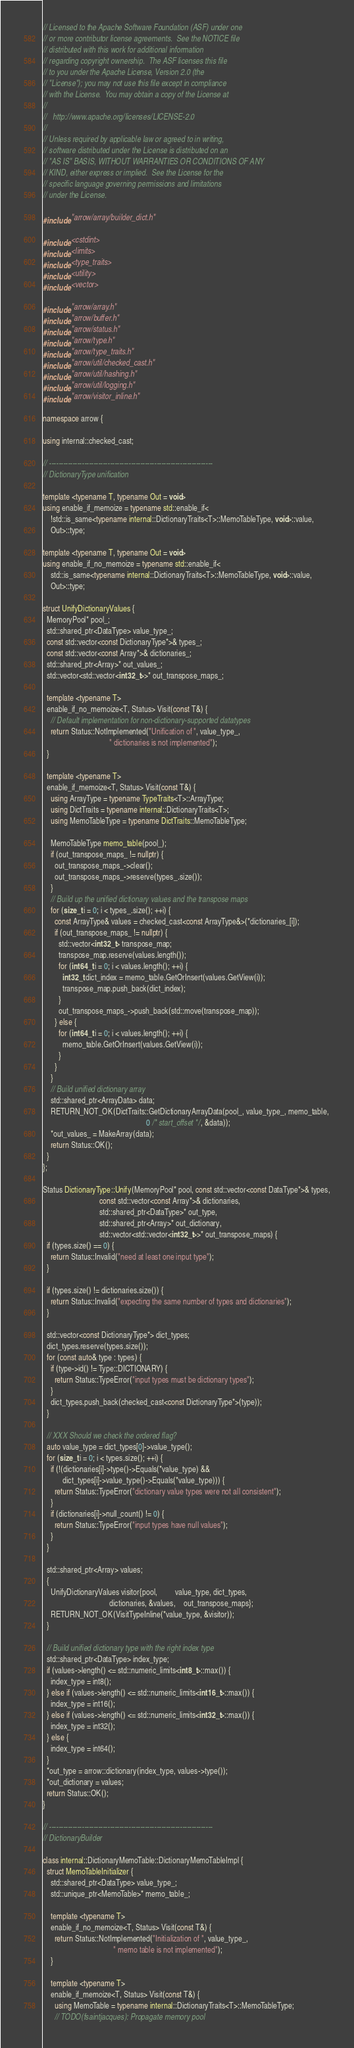Convert code to text. <code><loc_0><loc_0><loc_500><loc_500><_C++_>// Licensed to the Apache Software Foundation (ASF) under one
// or more contributor license agreements.  See the NOTICE file
// distributed with this work for additional information
// regarding copyright ownership.  The ASF licenses this file
// to you under the Apache License, Version 2.0 (the
// "License"); you may not use this file except in compliance
// with the License.  You may obtain a copy of the License at
//
//   http://www.apache.org/licenses/LICENSE-2.0
//
// Unless required by applicable law or agreed to in writing,
// software distributed under the License is distributed on an
// "AS IS" BASIS, WITHOUT WARRANTIES OR CONDITIONS OF ANY
// KIND, either express or implied.  See the License for the
// specific language governing permissions and limitations
// under the License.

#include "arrow/array/builder_dict.h"

#include <cstdint>
#include <limits>
#include <type_traits>
#include <utility>
#include <vector>

#include "arrow/array.h"
#include "arrow/buffer.h"
#include "arrow/status.h"
#include "arrow/type.h"
#include "arrow/type_traits.h"
#include "arrow/util/checked_cast.h"
#include "arrow/util/hashing.h"
#include "arrow/util/logging.h"
#include "arrow/visitor_inline.h"

namespace arrow {

using internal::checked_cast;

// ----------------------------------------------------------------------
// DictionaryType unification

template <typename T, typename Out = void>
using enable_if_memoize = typename std::enable_if<
    !std::is_same<typename internal::DictionaryTraits<T>::MemoTableType, void>::value,
    Out>::type;

template <typename T, typename Out = void>
using enable_if_no_memoize = typename std::enable_if<
    std::is_same<typename internal::DictionaryTraits<T>::MemoTableType, void>::value,
    Out>::type;

struct UnifyDictionaryValues {
  MemoryPool* pool_;
  std::shared_ptr<DataType> value_type_;
  const std::vector<const DictionaryType*>& types_;
  const std::vector<const Array*>& dictionaries_;
  std::shared_ptr<Array>* out_values_;
  std::vector<std::vector<int32_t>>* out_transpose_maps_;

  template <typename T>
  enable_if_no_memoize<T, Status> Visit(const T&) {
    // Default implementation for non-dictionary-supported datatypes
    return Status::NotImplemented("Unification of ", value_type_,
                                  " dictionaries is not implemented");
  }

  template <typename T>
  enable_if_memoize<T, Status> Visit(const T&) {
    using ArrayType = typename TypeTraits<T>::ArrayType;
    using DictTraits = typename internal::DictionaryTraits<T>;
    using MemoTableType = typename DictTraits::MemoTableType;

    MemoTableType memo_table(pool_);
    if (out_transpose_maps_ != nullptr) {
      out_transpose_maps_->clear();
      out_transpose_maps_->reserve(types_.size());
    }
    // Build up the unified dictionary values and the transpose maps
    for (size_t i = 0; i < types_.size(); ++i) {
      const ArrayType& values = checked_cast<const ArrayType&>(*dictionaries_[i]);
      if (out_transpose_maps_ != nullptr) {
        std::vector<int32_t> transpose_map;
        transpose_map.reserve(values.length());
        for (int64_t i = 0; i < values.length(); ++i) {
          int32_t dict_index = memo_table.GetOrInsert(values.GetView(i));
          transpose_map.push_back(dict_index);
        }
        out_transpose_maps_->push_back(std::move(transpose_map));
      } else {
        for (int64_t i = 0; i < values.length(); ++i) {
          memo_table.GetOrInsert(values.GetView(i));
        }
      }
    }
    // Build unified dictionary array
    std::shared_ptr<ArrayData> data;
    RETURN_NOT_OK(DictTraits::GetDictionaryArrayData(pool_, value_type_, memo_table,
                                                     0 /* start_offset */, &data));
    *out_values_ = MakeArray(data);
    return Status::OK();
  }
};

Status DictionaryType::Unify(MemoryPool* pool, const std::vector<const DataType*>& types,
                             const std::vector<const Array*>& dictionaries,
                             std::shared_ptr<DataType>* out_type,
                             std::shared_ptr<Array>* out_dictionary,
                             std::vector<std::vector<int32_t>>* out_transpose_maps) {
  if (types.size() == 0) {
    return Status::Invalid("need at least one input type");
  }

  if (types.size() != dictionaries.size()) {
    return Status::Invalid("expecting the same number of types and dictionaries");
  }

  std::vector<const DictionaryType*> dict_types;
  dict_types.reserve(types.size());
  for (const auto& type : types) {
    if (type->id() != Type::DICTIONARY) {
      return Status::TypeError("input types must be dictionary types");
    }
    dict_types.push_back(checked_cast<const DictionaryType*>(type));
  }

  // XXX Should we check the ordered flag?
  auto value_type = dict_types[0]->value_type();
  for (size_t i = 0; i < types.size(); ++i) {
    if (!(dictionaries[i]->type()->Equals(*value_type) &&
          dict_types[i]->value_type()->Equals(*value_type))) {
      return Status::TypeError("dictionary value types were not all consistent");
    }
    if (dictionaries[i]->null_count() != 0) {
      return Status::TypeError("input types have null values");
    }
  }

  std::shared_ptr<Array> values;
  {
    UnifyDictionaryValues visitor{pool,         value_type, dict_types,
                                  dictionaries, &values,    out_transpose_maps};
    RETURN_NOT_OK(VisitTypeInline(*value_type, &visitor));
  }

  // Build unified dictionary type with the right index type
  std::shared_ptr<DataType> index_type;
  if (values->length() <= std::numeric_limits<int8_t>::max()) {
    index_type = int8();
  } else if (values->length() <= std::numeric_limits<int16_t>::max()) {
    index_type = int16();
  } else if (values->length() <= std::numeric_limits<int32_t>::max()) {
    index_type = int32();
  } else {
    index_type = int64();
  }
  *out_type = arrow::dictionary(index_type, values->type());
  *out_dictionary = values;
  return Status::OK();
}

// ----------------------------------------------------------------------
// DictionaryBuilder

class internal::DictionaryMemoTable::DictionaryMemoTableImpl {
  struct MemoTableInitializer {
    std::shared_ptr<DataType> value_type_;
    std::unique_ptr<MemoTable>* memo_table_;

    template <typename T>
    enable_if_no_memoize<T, Status> Visit(const T&) {
      return Status::NotImplemented("Initialization of ", value_type_,
                                    " memo table is not implemented");
    }

    template <typename T>
    enable_if_memoize<T, Status> Visit(const T&) {
      using MemoTable = typename internal::DictionaryTraits<T>::MemoTableType;
      // TODO(fsaintjacques): Propagate memory pool</code> 